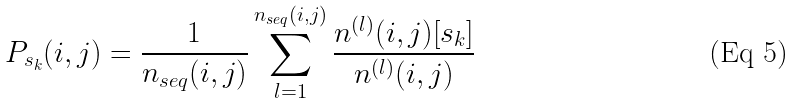<formula> <loc_0><loc_0><loc_500><loc_500>P _ { s _ { k } } ( i , j ) = \frac { 1 } { n _ { s e q } ( i , j ) } \sum _ { l = 1 } ^ { n _ { s e q } ( i , j ) } \frac { n ^ { ( l ) } ( i , j ) [ s _ { k } ] } { n ^ { ( l ) } ( i , j ) }</formula> 